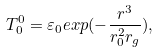<formula> <loc_0><loc_0><loc_500><loc_500>T ^ { 0 } _ { 0 } = \varepsilon _ { 0 } e x p ( - \frac { r ^ { 3 } } { r _ { 0 } ^ { 2 } r _ { g } } ) ,</formula> 